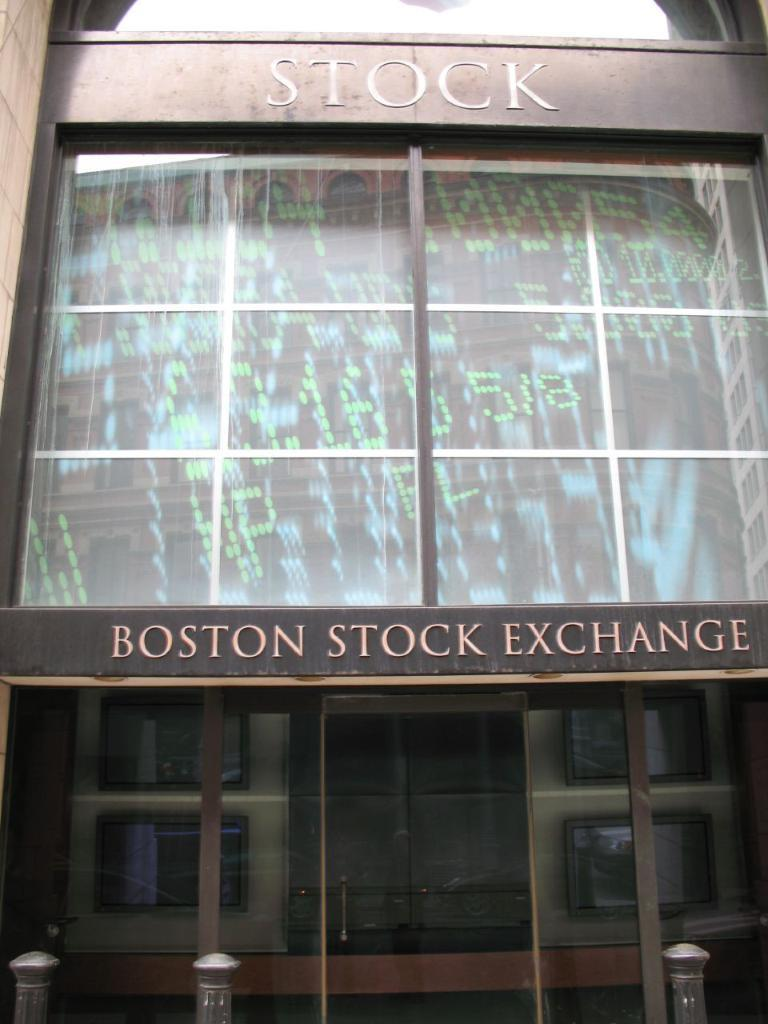What type of structure is visible in the image? There is a building in the image. What colors are used for the building? The building is black and brown in color. What other objects can be seen in the image? There are poles in the image. What type of windows does the building have? The building has glass windows. Is there any text or writing on the building? Yes, there is text or writing on the building. How many lizards are climbing on the building in the image? There are no lizards present in the image; it only features a building, poles, and text or writing. What color is the crayon used to write on the building? There is no crayon present in the image; the text or writing on the building is not specified as being written with a crayon. 